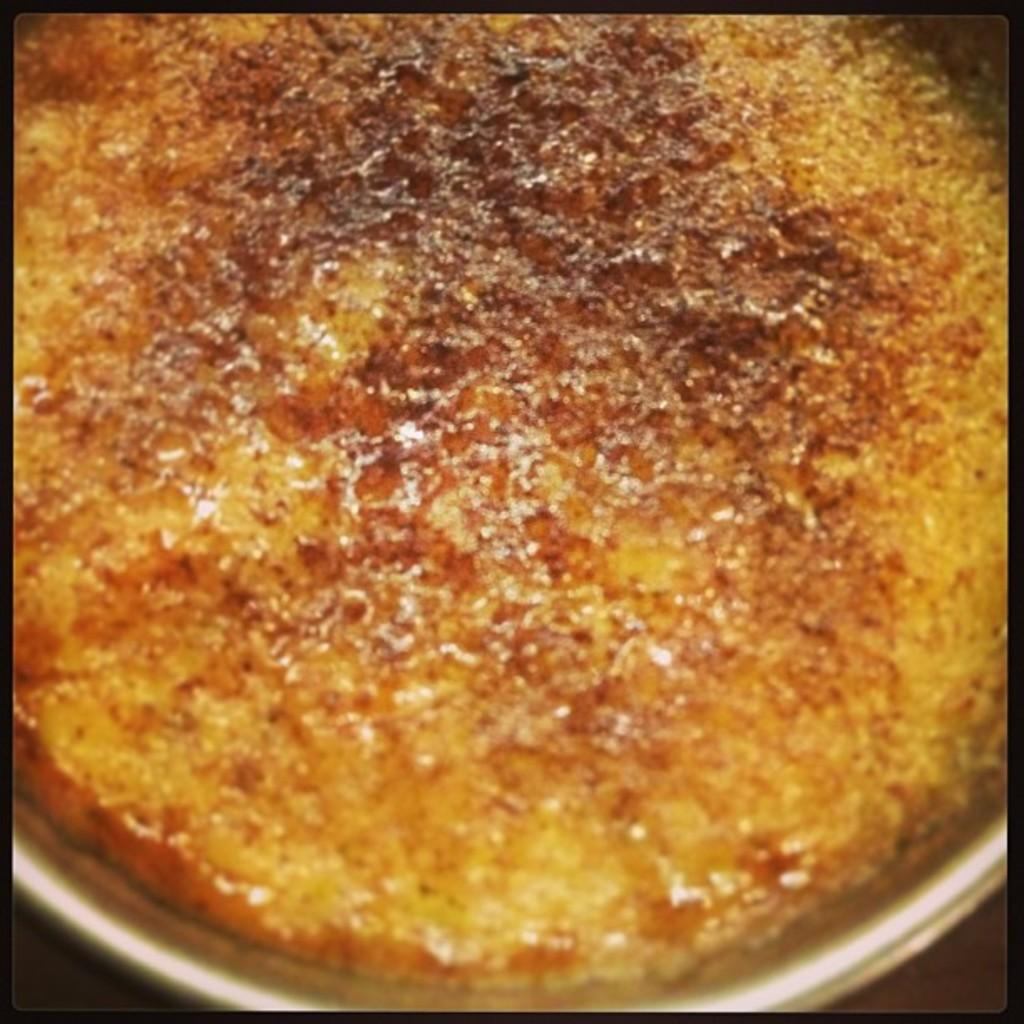What is on the plate in the image? There is a food item on a plate in the image. What type of liquid can be seen in the drawer in the image? There is no drawer or liquid present in the image; it only features a food item on a plate. 